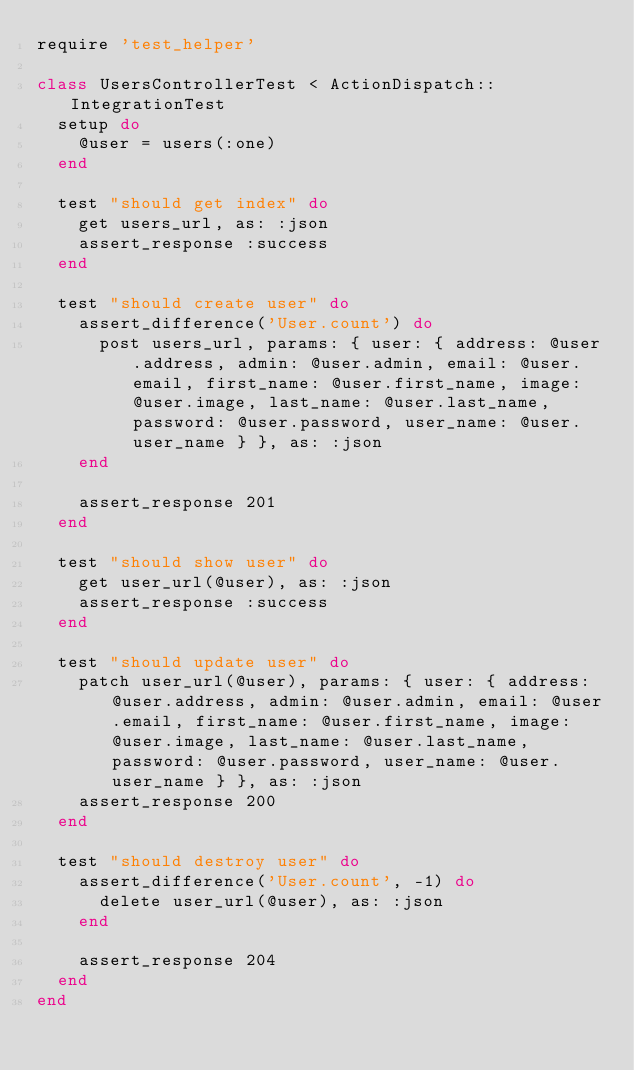Convert code to text. <code><loc_0><loc_0><loc_500><loc_500><_Ruby_>require 'test_helper'

class UsersControllerTest < ActionDispatch::IntegrationTest
  setup do
    @user = users(:one)
  end

  test "should get index" do
    get users_url, as: :json
    assert_response :success
  end

  test "should create user" do
    assert_difference('User.count') do
      post users_url, params: { user: { address: @user.address, admin: @user.admin, email: @user.email, first_name: @user.first_name, image: @user.image, last_name: @user.last_name, password: @user.password, user_name: @user.user_name } }, as: :json
    end

    assert_response 201
  end

  test "should show user" do
    get user_url(@user), as: :json
    assert_response :success
  end

  test "should update user" do
    patch user_url(@user), params: { user: { address: @user.address, admin: @user.admin, email: @user.email, first_name: @user.first_name, image: @user.image, last_name: @user.last_name, password: @user.password, user_name: @user.user_name } }, as: :json
    assert_response 200
  end

  test "should destroy user" do
    assert_difference('User.count', -1) do
      delete user_url(@user), as: :json
    end

    assert_response 204
  end
end
</code> 